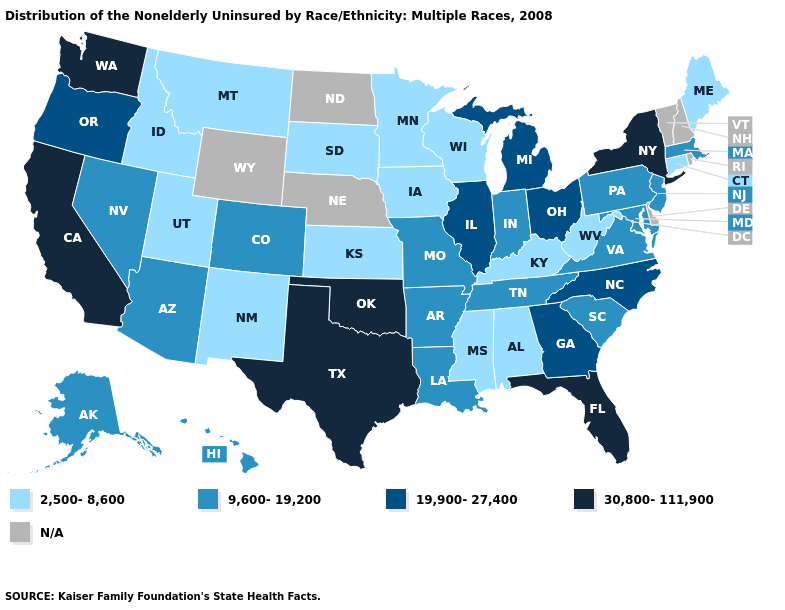Which states have the lowest value in the West?
Be succinct. Idaho, Montana, New Mexico, Utah. What is the lowest value in states that border Delaware?
Quick response, please. 9,600-19,200. Does Connecticut have the lowest value in the Northeast?
Give a very brief answer. Yes. What is the highest value in the USA?
Write a very short answer. 30,800-111,900. Name the states that have a value in the range 9,600-19,200?
Quick response, please. Alaska, Arizona, Arkansas, Colorado, Hawaii, Indiana, Louisiana, Maryland, Massachusetts, Missouri, Nevada, New Jersey, Pennsylvania, South Carolina, Tennessee, Virginia. What is the value of Nebraska?
Write a very short answer. N/A. Which states have the lowest value in the USA?
Concise answer only. Alabama, Connecticut, Idaho, Iowa, Kansas, Kentucky, Maine, Minnesota, Mississippi, Montana, New Mexico, South Dakota, Utah, West Virginia, Wisconsin. What is the highest value in states that border Idaho?
Answer briefly. 30,800-111,900. Among the states that border Louisiana , which have the highest value?
Write a very short answer. Texas. What is the value of New Jersey?
Short answer required. 9,600-19,200. What is the value of Georgia?
Quick response, please. 19,900-27,400. Does the first symbol in the legend represent the smallest category?
Answer briefly. Yes. What is the lowest value in the Northeast?
Be succinct. 2,500-8,600. What is the value of Tennessee?
Concise answer only. 9,600-19,200. 